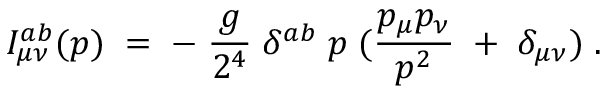<formula> <loc_0><loc_0><loc_500><loc_500>I _ { \mu \nu } ^ { a b } ( p ) \, = \, - \, \frac { g } { 2 ^ { 4 } } \, \delta ^ { a b } \, p \, ( \frac { p _ { \mu } p _ { \nu } } { p ^ { 2 } } \, + \, \delta _ { \mu \nu } ) \, .</formula> 